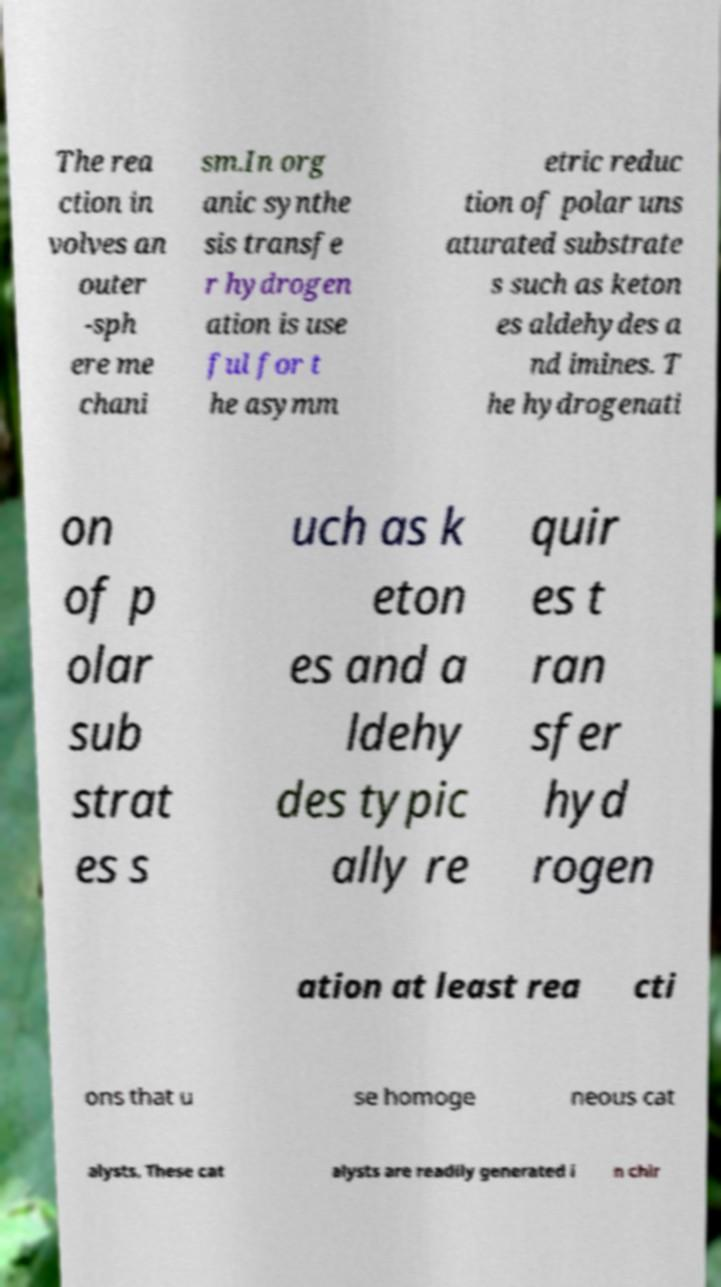Please identify and transcribe the text found in this image. The rea ction in volves an outer -sph ere me chani sm.In org anic synthe sis transfe r hydrogen ation is use ful for t he asymm etric reduc tion of polar uns aturated substrate s such as keton es aldehydes a nd imines. T he hydrogenati on of p olar sub strat es s uch as k eton es and a ldehy des typic ally re quir es t ran sfer hyd rogen ation at least rea cti ons that u se homoge neous cat alysts. These cat alysts are readily generated i n chir 